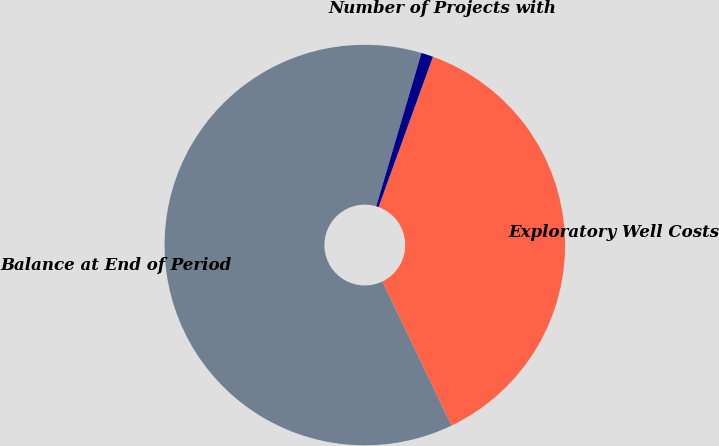<chart> <loc_0><loc_0><loc_500><loc_500><pie_chart><fcel>Exploratory Well Costs<fcel>Balance at End of Period<fcel>Number of Projects with<nl><fcel>37.35%<fcel>61.69%<fcel>0.96%<nl></chart> 